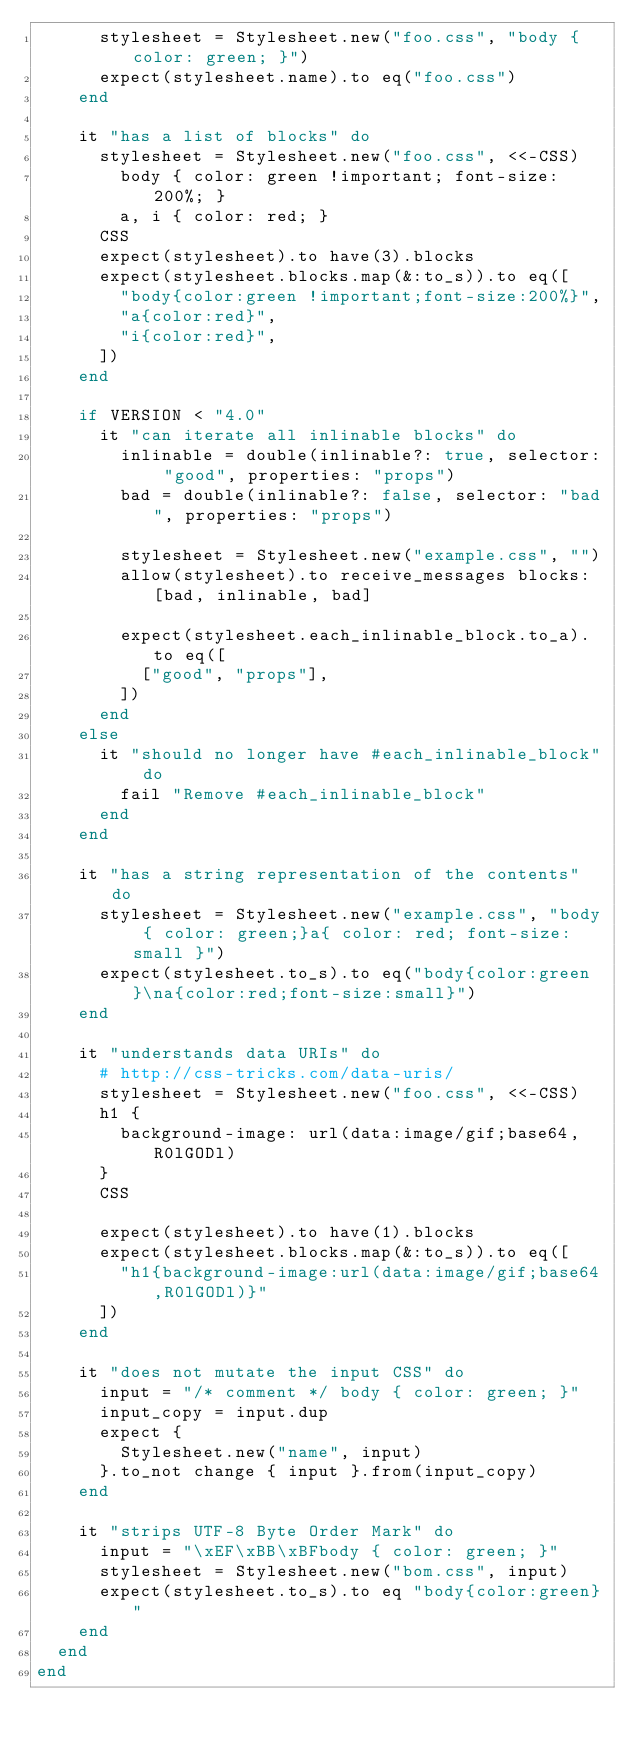<code> <loc_0><loc_0><loc_500><loc_500><_Ruby_>      stylesheet = Stylesheet.new("foo.css", "body { color: green; }")
      expect(stylesheet.name).to eq("foo.css")
    end

    it "has a list of blocks" do
      stylesheet = Stylesheet.new("foo.css", <<-CSS)
        body { color: green !important; font-size: 200%; }
        a, i { color: red; }
      CSS
      expect(stylesheet).to have(3).blocks
      expect(stylesheet.blocks.map(&:to_s)).to eq([
        "body{color:green !important;font-size:200%}",
        "a{color:red}",
        "i{color:red}",
      ])
    end

    if VERSION < "4.0"
      it "can iterate all inlinable blocks" do
        inlinable = double(inlinable?: true, selector: "good", properties: "props")
        bad = double(inlinable?: false, selector: "bad", properties: "props")

        stylesheet = Stylesheet.new("example.css", "")
        allow(stylesheet).to receive_messages blocks: [bad, inlinable, bad]

        expect(stylesheet.each_inlinable_block.to_a).to eq([
          ["good", "props"],
        ])
      end
    else
      it "should no longer have #each_inlinable_block" do
        fail "Remove #each_inlinable_block"
      end
    end

    it "has a string representation of the contents" do
      stylesheet = Stylesheet.new("example.css", "body { color: green;}a{ color: red; font-size: small }")
      expect(stylesheet.to_s).to eq("body{color:green}\na{color:red;font-size:small}")
    end

    it "understands data URIs" do
      # http://css-tricks.com/data-uris/
      stylesheet = Stylesheet.new("foo.css", <<-CSS)
      h1 {
        background-image: url(data:image/gif;base64,R0lGODl)
      }
      CSS

      expect(stylesheet).to have(1).blocks
      expect(stylesheet.blocks.map(&:to_s)).to eq([
        "h1{background-image:url(data:image/gif;base64,R0lGODl)}"
      ])
    end

    it "does not mutate the input CSS" do
      input = "/* comment */ body { color: green; }"
      input_copy = input.dup
      expect {
        Stylesheet.new("name", input)
      }.to_not change { input }.from(input_copy)
    end

    it "strips UTF-8 Byte Order Mark" do
      input = "\xEF\xBB\xBFbody { color: green; }"
      stylesheet = Stylesheet.new("bom.css", input)
      expect(stylesheet.to_s).to eq "body{color:green}"
    end
  end
end
</code> 